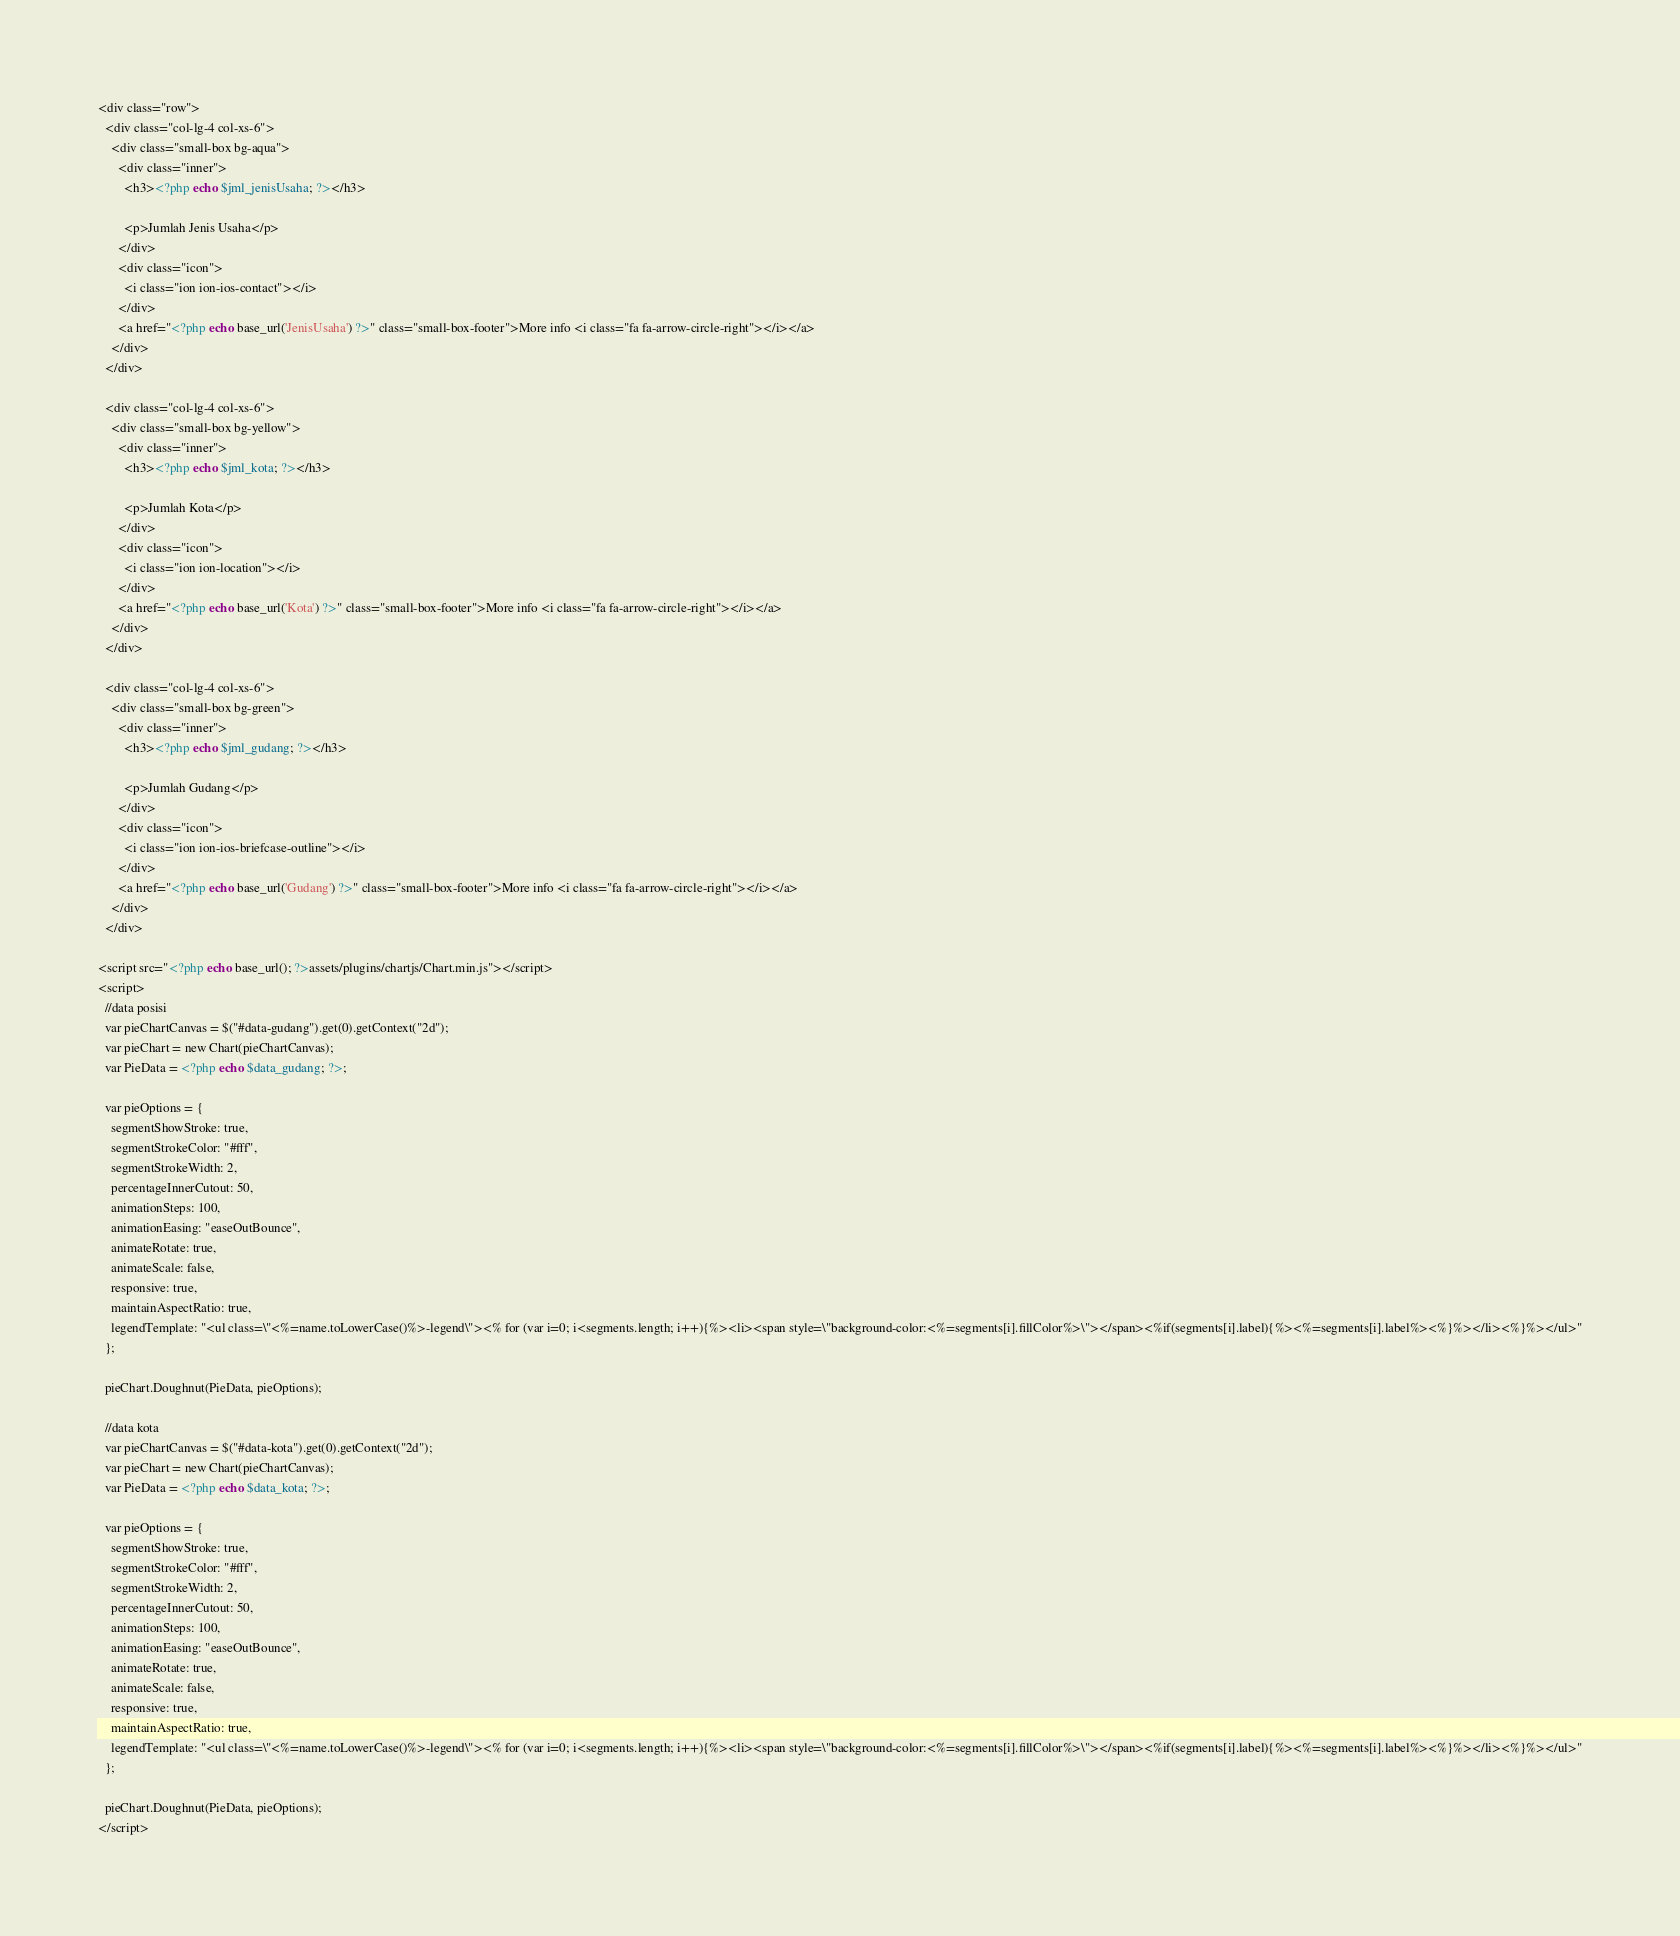<code> <loc_0><loc_0><loc_500><loc_500><_PHP_><div class="row">
  <div class="col-lg-4 col-xs-6">
    <div class="small-box bg-aqua">
      <div class="inner">
        <h3><?php echo $jml_jenisUsaha; ?></h3>

        <p>Jumlah Jenis Usaha</p>
      </div>
      <div class="icon">
        <i class="ion ion-ios-contact"></i>
      </div>
      <a href="<?php echo base_url('JenisUsaha') ?>" class="small-box-footer">More info <i class="fa fa-arrow-circle-right"></i></a>
    </div>
  </div>

  <div class="col-lg-4 col-xs-6">
    <div class="small-box bg-yellow">
      <div class="inner">
        <h3><?php echo $jml_kota; ?></h3>

        <p>Jumlah Kota</p>
      </div>
      <div class="icon">
        <i class="ion ion-location"></i>
      </div>
      <a href="<?php echo base_url('Kota') ?>" class="small-box-footer">More info <i class="fa fa-arrow-circle-right"></i></a>
    </div>
  </div>

  <div class="col-lg-4 col-xs-6">
    <div class="small-box bg-green">
      <div class="inner">
        <h3><?php echo $jml_gudang; ?></h3>

        <p>Jumlah Gudang</p>
      </div>
      <div class="icon">
        <i class="ion ion-ios-briefcase-outline"></i>
      </div>
      <a href="<?php echo base_url('Gudang') ?>" class="small-box-footer">More info <i class="fa fa-arrow-circle-right"></i></a>
    </div>
  </div>

<script src="<?php echo base_url(); ?>assets/plugins/chartjs/Chart.min.js"></script>
<script>
  //data posisi
  var pieChartCanvas = $("#data-gudang").get(0).getContext("2d");
  var pieChart = new Chart(pieChartCanvas);
  var PieData = <?php echo $data_gudang; ?>;

  var pieOptions = {
    segmentShowStroke: true,
    segmentStrokeColor: "#fff",
    segmentStrokeWidth: 2,
    percentageInnerCutout: 50,
    animationSteps: 100,
    animationEasing: "easeOutBounce",
    animateRotate: true,
    animateScale: false,
    responsive: true,
    maintainAspectRatio: true,
    legendTemplate: "<ul class=\"<%=name.toLowerCase()%>-legend\"><% for (var i=0; i<segments.length; i++){%><li><span style=\"background-color:<%=segments[i].fillColor%>\"></span><%if(segments[i].label){%><%=segments[i].label%><%}%></li><%}%></ul>"
  };

  pieChart.Doughnut(PieData, pieOptions);

  //data kota
  var pieChartCanvas = $("#data-kota").get(0).getContext("2d");
  var pieChart = new Chart(pieChartCanvas);
  var PieData = <?php echo $data_kota; ?>;

  var pieOptions = {
    segmentShowStroke: true,
    segmentStrokeColor: "#fff",
    segmentStrokeWidth: 2,
    percentageInnerCutout: 50,
    animationSteps: 100,
    animationEasing: "easeOutBounce",
    animateRotate: true,
    animateScale: false,
    responsive: true,
    maintainAspectRatio: true,
    legendTemplate: "<ul class=\"<%=name.toLowerCase()%>-legend\"><% for (var i=0; i<segments.length; i++){%><li><span style=\"background-color:<%=segments[i].fillColor%>\"></span><%if(segments[i].label){%><%=segments[i].label%><%}%></li><%}%></ul>"
  };

  pieChart.Doughnut(PieData, pieOptions);
</script>
</code> 